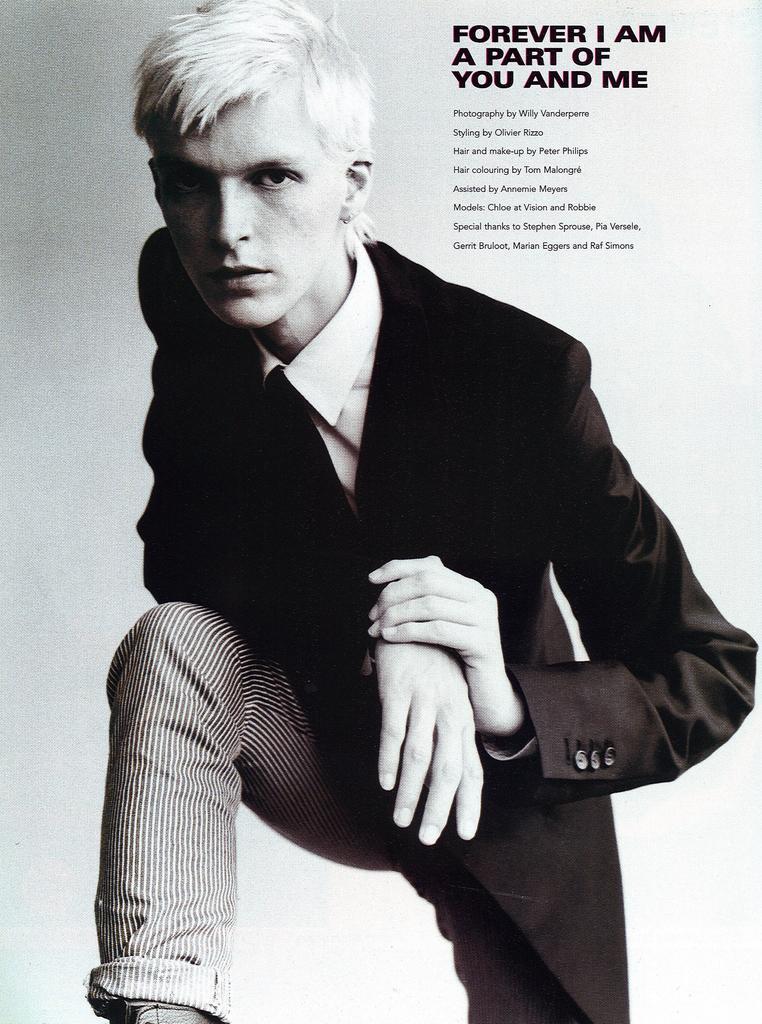Could you give a brief overview of what you see in this image? In this image, we can see a person wearing clothes and there is a text in the top right of the image. 